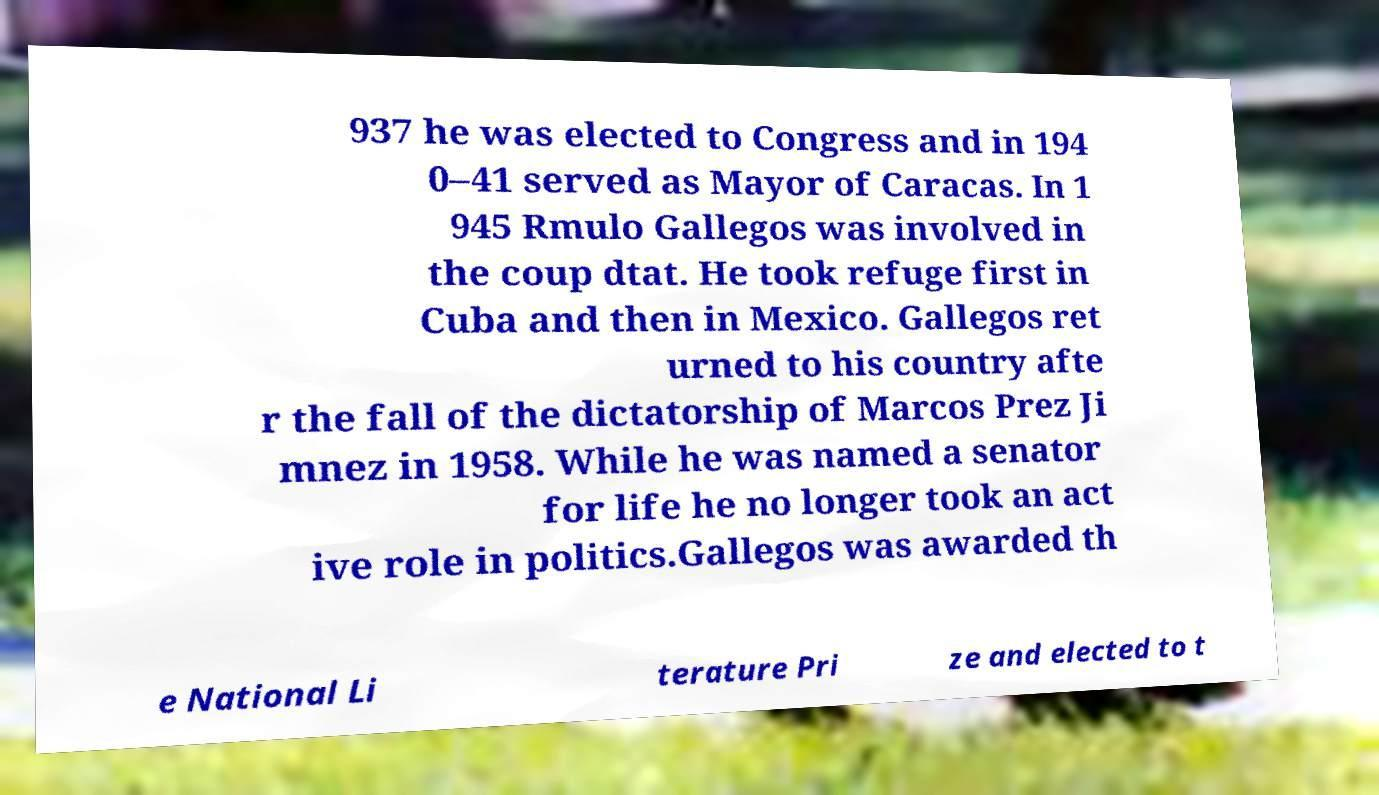I need the written content from this picture converted into text. Can you do that? 937 he was elected to Congress and in 194 0–41 served as Mayor of Caracas. In 1 945 Rmulo Gallegos was involved in the coup dtat. He took refuge first in Cuba and then in Mexico. Gallegos ret urned to his country afte r the fall of the dictatorship of Marcos Prez Ji mnez in 1958. While he was named a senator for life he no longer took an act ive role in politics.Gallegos was awarded th e National Li terature Pri ze and elected to t 